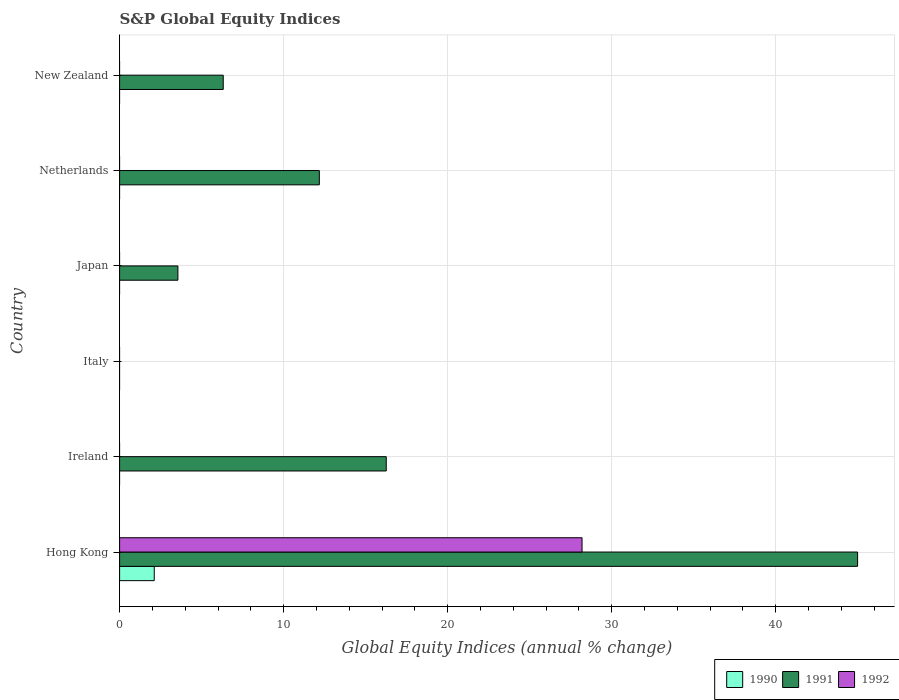Are the number of bars on each tick of the Y-axis equal?
Provide a short and direct response. No. How many bars are there on the 4th tick from the bottom?
Ensure brevity in your answer.  1. What is the label of the 4th group of bars from the top?
Provide a short and direct response. Italy. What is the global equity indices in 1992 in Italy?
Your response must be concise. 0. Across all countries, what is the maximum global equity indices in 1992?
Ensure brevity in your answer.  28.19. In which country was the global equity indices in 1991 maximum?
Your answer should be compact. Hong Kong. What is the total global equity indices in 1991 in the graph?
Make the answer very short. 83.3. What is the difference between the global equity indices in 1991 in Ireland and that in New Zealand?
Your answer should be very brief. 9.94. What is the difference between the global equity indices in 1990 in New Zealand and the global equity indices in 1992 in Japan?
Make the answer very short. 0. What is the average global equity indices in 1991 per country?
Provide a short and direct response. 13.88. What is the difference between the global equity indices in 1991 and global equity indices in 1992 in Hong Kong?
Keep it short and to the point. 16.8. In how many countries, is the global equity indices in 1992 greater than 6 %?
Give a very brief answer. 1. What is the ratio of the global equity indices in 1991 in Netherlands to that in New Zealand?
Ensure brevity in your answer.  1.93. Is the global equity indices in 1991 in Japan less than that in New Zealand?
Your response must be concise. Yes. What is the difference between the highest and the second highest global equity indices in 1991?
Your answer should be compact. 28.74. What is the difference between the highest and the lowest global equity indices in 1992?
Provide a succinct answer. 28.19. In how many countries, is the global equity indices in 1990 greater than the average global equity indices in 1990 taken over all countries?
Give a very brief answer. 1. Is the sum of the global equity indices in 1991 in Netherlands and New Zealand greater than the maximum global equity indices in 1990 across all countries?
Your answer should be very brief. Yes. Is it the case that in every country, the sum of the global equity indices in 1990 and global equity indices in 1992 is greater than the global equity indices in 1991?
Keep it short and to the point. No. Are all the bars in the graph horizontal?
Keep it short and to the point. Yes. How many countries are there in the graph?
Keep it short and to the point. 6. Does the graph contain grids?
Your answer should be very brief. Yes. How are the legend labels stacked?
Give a very brief answer. Horizontal. What is the title of the graph?
Keep it short and to the point. S&P Global Equity Indices. What is the label or title of the X-axis?
Provide a succinct answer. Global Equity Indices (annual % change). What is the Global Equity Indices (annual % change) of 1990 in Hong Kong?
Provide a succinct answer. 2.11. What is the Global Equity Indices (annual % change) of 1991 in Hong Kong?
Your answer should be very brief. 44.99. What is the Global Equity Indices (annual % change) in 1992 in Hong Kong?
Provide a succinct answer. 28.19. What is the Global Equity Indices (annual % change) of 1991 in Ireland?
Ensure brevity in your answer.  16.26. What is the Global Equity Indices (annual % change) in 1992 in Italy?
Ensure brevity in your answer.  0. What is the Global Equity Indices (annual % change) of 1990 in Japan?
Offer a terse response. 0. What is the Global Equity Indices (annual % change) in 1991 in Japan?
Give a very brief answer. 3.55. What is the Global Equity Indices (annual % change) of 1992 in Japan?
Your response must be concise. 0. What is the Global Equity Indices (annual % change) of 1990 in Netherlands?
Offer a very short reply. 0. What is the Global Equity Indices (annual % change) of 1991 in Netherlands?
Your answer should be very brief. 12.18. What is the Global Equity Indices (annual % change) of 1991 in New Zealand?
Your answer should be compact. 6.32. Across all countries, what is the maximum Global Equity Indices (annual % change) of 1990?
Offer a terse response. 2.11. Across all countries, what is the maximum Global Equity Indices (annual % change) in 1991?
Keep it short and to the point. 44.99. Across all countries, what is the maximum Global Equity Indices (annual % change) of 1992?
Offer a terse response. 28.19. What is the total Global Equity Indices (annual % change) of 1990 in the graph?
Your answer should be compact. 2.11. What is the total Global Equity Indices (annual % change) of 1991 in the graph?
Your answer should be very brief. 83.3. What is the total Global Equity Indices (annual % change) of 1992 in the graph?
Your answer should be compact. 28.19. What is the difference between the Global Equity Indices (annual % change) in 1991 in Hong Kong and that in Ireland?
Give a very brief answer. 28.74. What is the difference between the Global Equity Indices (annual % change) of 1991 in Hong Kong and that in Japan?
Your answer should be very brief. 41.44. What is the difference between the Global Equity Indices (annual % change) of 1991 in Hong Kong and that in Netherlands?
Give a very brief answer. 32.82. What is the difference between the Global Equity Indices (annual % change) of 1991 in Hong Kong and that in New Zealand?
Ensure brevity in your answer.  38.67. What is the difference between the Global Equity Indices (annual % change) in 1991 in Ireland and that in Japan?
Provide a short and direct response. 12.7. What is the difference between the Global Equity Indices (annual % change) of 1991 in Ireland and that in Netherlands?
Make the answer very short. 4.08. What is the difference between the Global Equity Indices (annual % change) of 1991 in Ireland and that in New Zealand?
Make the answer very short. 9.94. What is the difference between the Global Equity Indices (annual % change) of 1991 in Japan and that in Netherlands?
Ensure brevity in your answer.  -8.62. What is the difference between the Global Equity Indices (annual % change) of 1991 in Japan and that in New Zealand?
Your answer should be very brief. -2.76. What is the difference between the Global Equity Indices (annual % change) of 1991 in Netherlands and that in New Zealand?
Offer a very short reply. 5.86. What is the difference between the Global Equity Indices (annual % change) in 1990 in Hong Kong and the Global Equity Indices (annual % change) in 1991 in Ireland?
Give a very brief answer. -14.14. What is the difference between the Global Equity Indices (annual % change) in 1990 in Hong Kong and the Global Equity Indices (annual % change) in 1991 in Japan?
Your answer should be compact. -1.44. What is the difference between the Global Equity Indices (annual % change) of 1990 in Hong Kong and the Global Equity Indices (annual % change) of 1991 in Netherlands?
Your answer should be very brief. -10.06. What is the difference between the Global Equity Indices (annual % change) of 1990 in Hong Kong and the Global Equity Indices (annual % change) of 1991 in New Zealand?
Make the answer very short. -4.21. What is the average Global Equity Indices (annual % change) in 1990 per country?
Your answer should be very brief. 0.35. What is the average Global Equity Indices (annual % change) in 1991 per country?
Your answer should be compact. 13.88. What is the average Global Equity Indices (annual % change) of 1992 per country?
Your answer should be compact. 4.7. What is the difference between the Global Equity Indices (annual % change) of 1990 and Global Equity Indices (annual % change) of 1991 in Hong Kong?
Provide a short and direct response. -42.88. What is the difference between the Global Equity Indices (annual % change) in 1990 and Global Equity Indices (annual % change) in 1992 in Hong Kong?
Your answer should be very brief. -26.08. What is the difference between the Global Equity Indices (annual % change) of 1991 and Global Equity Indices (annual % change) of 1992 in Hong Kong?
Offer a terse response. 16.8. What is the ratio of the Global Equity Indices (annual % change) in 1991 in Hong Kong to that in Ireland?
Offer a terse response. 2.77. What is the ratio of the Global Equity Indices (annual % change) in 1991 in Hong Kong to that in Japan?
Keep it short and to the point. 12.66. What is the ratio of the Global Equity Indices (annual % change) in 1991 in Hong Kong to that in Netherlands?
Give a very brief answer. 3.69. What is the ratio of the Global Equity Indices (annual % change) in 1991 in Hong Kong to that in New Zealand?
Provide a short and direct response. 7.12. What is the ratio of the Global Equity Indices (annual % change) of 1991 in Ireland to that in Japan?
Your answer should be very brief. 4.57. What is the ratio of the Global Equity Indices (annual % change) of 1991 in Ireland to that in Netherlands?
Give a very brief answer. 1.34. What is the ratio of the Global Equity Indices (annual % change) of 1991 in Ireland to that in New Zealand?
Make the answer very short. 2.57. What is the ratio of the Global Equity Indices (annual % change) in 1991 in Japan to that in Netherlands?
Provide a short and direct response. 0.29. What is the ratio of the Global Equity Indices (annual % change) of 1991 in Japan to that in New Zealand?
Provide a succinct answer. 0.56. What is the ratio of the Global Equity Indices (annual % change) of 1991 in Netherlands to that in New Zealand?
Offer a terse response. 1.93. What is the difference between the highest and the second highest Global Equity Indices (annual % change) in 1991?
Provide a short and direct response. 28.74. What is the difference between the highest and the lowest Global Equity Indices (annual % change) of 1990?
Your answer should be compact. 2.11. What is the difference between the highest and the lowest Global Equity Indices (annual % change) of 1991?
Your answer should be compact. 44.99. What is the difference between the highest and the lowest Global Equity Indices (annual % change) in 1992?
Make the answer very short. 28.19. 